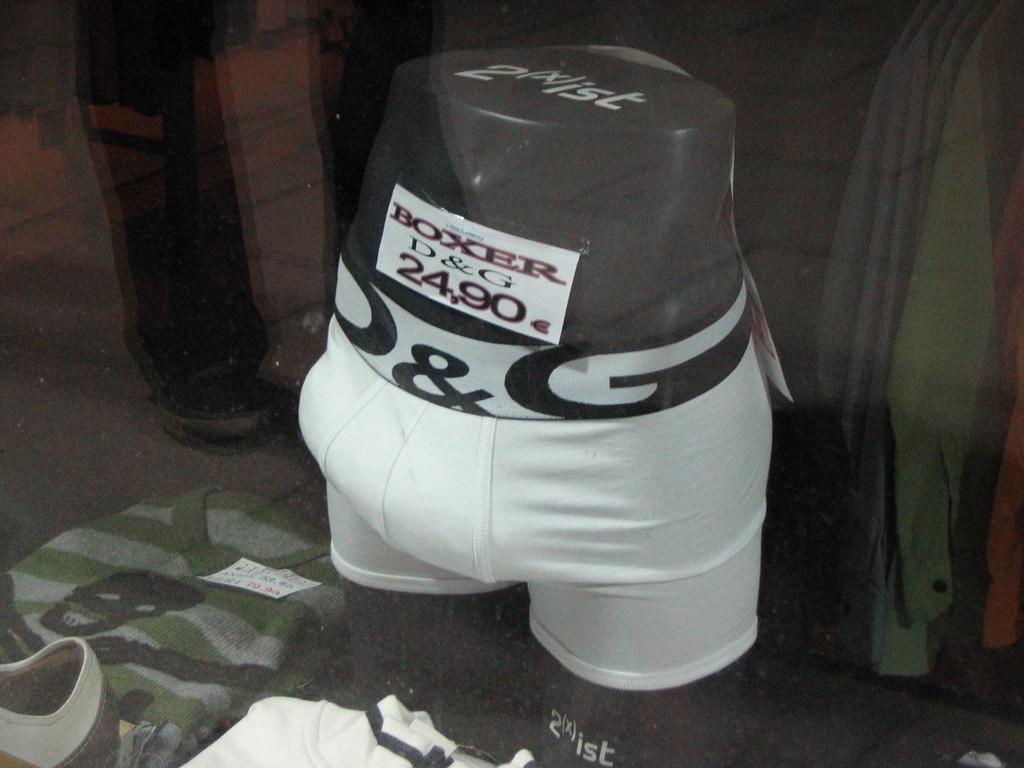Please provide a concise description of this image. In this image I can see short to the mannequin, around I can see some shirts. 